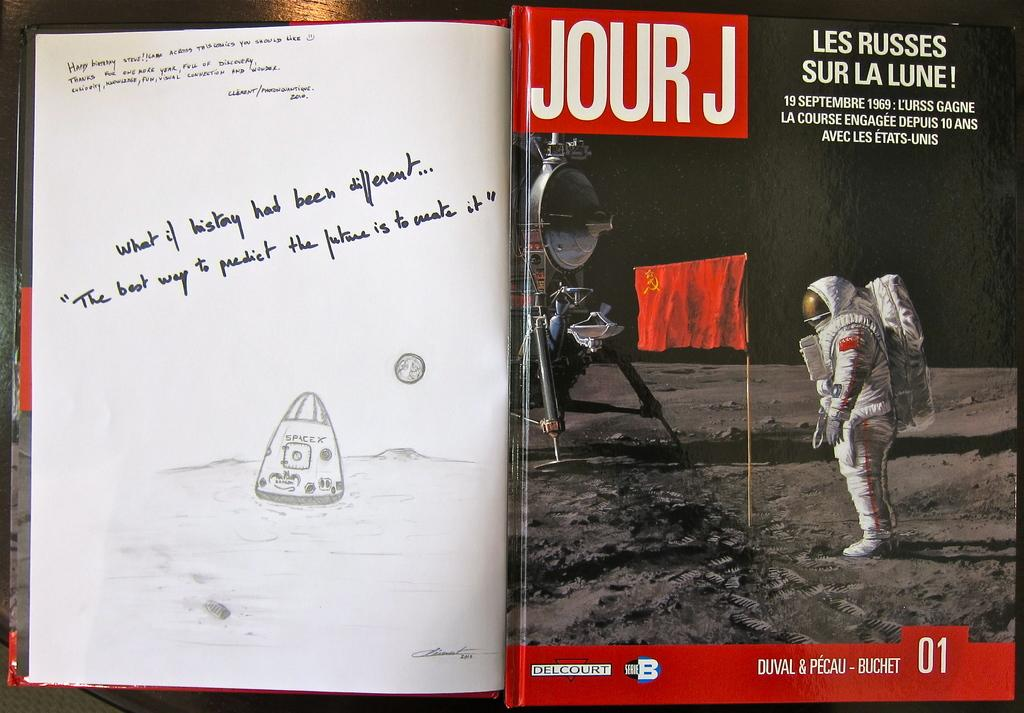<image>
Summarize the visual content of the image. a magazine on sicience called Jour J wit ha drawing 